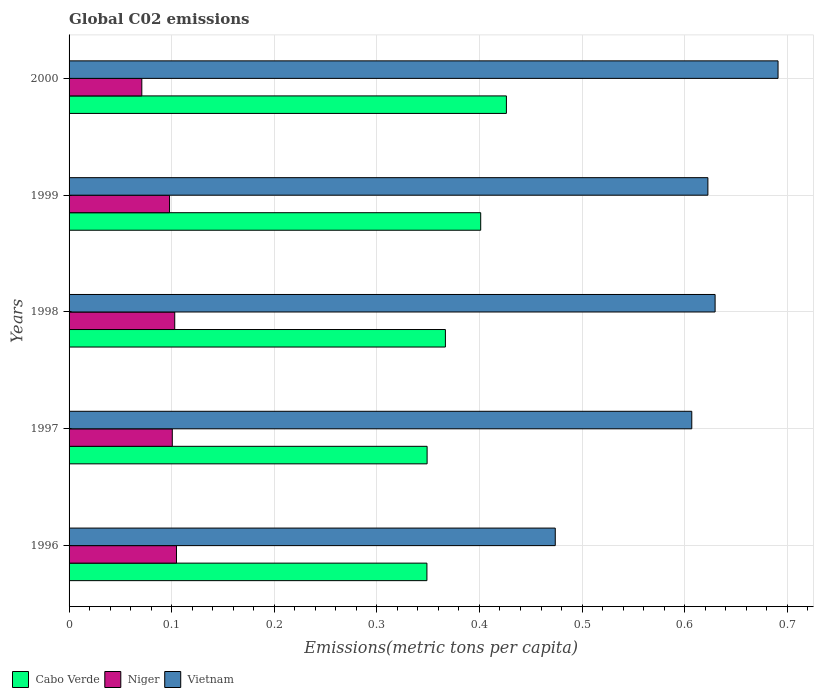Are the number of bars per tick equal to the number of legend labels?
Your answer should be compact. Yes. How many bars are there on the 2nd tick from the bottom?
Ensure brevity in your answer.  3. What is the label of the 3rd group of bars from the top?
Make the answer very short. 1998. What is the amount of CO2 emitted in in Vietnam in 1998?
Keep it short and to the point. 0.63. Across all years, what is the maximum amount of CO2 emitted in in Cabo Verde?
Your answer should be compact. 0.43. Across all years, what is the minimum amount of CO2 emitted in in Vietnam?
Your answer should be compact. 0.47. In which year was the amount of CO2 emitted in in Niger minimum?
Provide a succinct answer. 2000. What is the total amount of CO2 emitted in in Niger in the graph?
Your answer should be very brief. 0.48. What is the difference between the amount of CO2 emitted in in Niger in 1996 and that in 1997?
Your answer should be very brief. 0. What is the difference between the amount of CO2 emitted in in Vietnam in 1996 and the amount of CO2 emitted in in Niger in 2000?
Your answer should be very brief. 0.4. What is the average amount of CO2 emitted in in Niger per year?
Keep it short and to the point. 0.1. In the year 1998, what is the difference between the amount of CO2 emitted in in Cabo Verde and amount of CO2 emitted in in Vietnam?
Keep it short and to the point. -0.26. What is the ratio of the amount of CO2 emitted in in Cabo Verde in 1998 to that in 2000?
Give a very brief answer. 0.86. Is the amount of CO2 emitted in in Cabo Verde in 1999 less than that in 2000?
Your response must be concise. Yes. What is the difference between the highest and the second highest amount of CO2 emitted in in Cabo Verde?
Your answer should be very brief. 0.03. What is the difference between the highest and the lowest amount of CO2 emitted in in Vietnam?
Keep it short and to the point. 0.22. What does the 1st bar from the top in 2000 represents?
Ensure brevity in your answer.  Vietnam. What does the 1st bar from the bottom in 1999 represents?
Keep it short and to the point. Cabo Verde. Is it the case that in every year, the sum of the amount of CO2 emitted in in Niger and amount of CO2 emitted in in Cabo Verde is greater than the amount of CO2 emitted in in Vietnam?
Make the answer very short. No. How many bars are there?
Provide a short and direct response. 15. Are all the bars in the graph horizontal?
Give a very brief answer. Yes. What is the difference between two consecutive major ticks on the X-axis?
Your answer should be compact. 0.1. Are the values on the major ticks of X-axis written in scientific E-notation?
Keep it short and to the point. No. Does the graph contain any zero values?
Give a very brief answer. No. Where does the legend appear in the graph?
Ensure brevity in your answer.  Bottom left. How many legend labels are there?
Offer a terse response. 3. How are the legend labels stacked?
Make the answer very short. Horizontal. What is the title of the graph?
Your response must be concise. Global C02 emissions. What is the label or title of the X-axis?
Provide a short and direct response. Emissions(metric tons per capita). What is the Emissions(metric tons per capita) in Cabo Verde in 1996?
Offer a very short reply. 0.35. What is the Emissions(metric tons per capita) of Niger in 1996?
Your response must be concise. 0.1. What is the Emissions(metric tons per capita) of Vietnam in 1996?
Offer a very short reply. 0.47. What is the Emissions(metric tons per capita) in Cabo Verde in 1997?
Provide a succinct answer. 0.35. What is the Emissions(metric tons per capita) in Niger in 1997?
Offer a terse response. 0.1. What is the Emissions(metric tons per capita) in Vietnam in 1997?
Ensure brevity in your answer.  0.61. What is the Emissions(metric tons per capita) of Cabo Verde in 1998?
Give a very brief answer. 0.37. What is the Emissions(metric tons per capita) of Niger in 1998?
Ensure brevity in your answer.  0.1. What is the Emissions(metric tons per capita) of Vietnam in 1998?
Give a very brief answer. 0.63. What is the Emissions(metric tons per capita) in Cabo Verde in 1999?
Your answer should be compact. 0.4. What is the Emissions(metric tons per capita) of Niger in 1999?
Provide a succinct answer. 0.1. What is the Emissions(metric tons per capita) of Vietnam in 1999?
Offer a very short reply. 0.62. What is the Emissions(metric tons per capita) of Cabo Verde in 2000?
Ensure brevity in your answer.  0.43. What is the Emissions(metric tons per capita) in Niger in 2000?
Keep it short and to the point. 0.07. What is the Emissions(metric tons per capita) of Vietnam in 2000?
Your response must be concise. 0.69. Across all years, what is the maximum Emissions(metric tons per capita) in Cabo Verde?
Keep it short and to the point. 0.43. Across all years, what is the maximum Emissions(metric tons per capita) of Niger?
Provide a short and direct response. 0.1. Across all years, what is the maximum Emissions(metric tons per capita) in Vietnam?
Offer a terse response. 0.69. Across all years, what is the minimum Emissions(metric tons per capita) of Cabo Verde?
Provide a succinct answer. 0.35. Across all years, what is the minimum Emissions(metric tons per capita) in Niger?
Make the answer very short. 0.07. Across all years, what is the minimum Emissions(metric tons per capita) of Vietnam?
Make the answer very short. 0.47. What is the total Emissions(metric tons per capita) of Cabo Verde in the graph?
Provide a short and direct response. 1.89. What is the total Emissions(metric tons per capita) of Niger in the graph?
Give a very brief answer. 0.48. What is the total Emissions(metric tons per capita) of Vietnam in the graph?
Your answer should be very brief. 3.02. What is the difference between the Emissions(metric tons per capita) in Cabo Verde in 1996 and that in 1997?
Keep it short and to the point. -0. What is the difference between the Emissions(metric tons per capita) in Niger in 1996 and that in 1997?
Your answer should be compact. 0. What is the difference between the Emissions(metric tons per capita) in Vietnam in 1996 and that in 1997?
Provide a succinct answer. -0.13. What is the difference between the Emissions(metric tons per capita) of Cabo Verde in 1996 and that in 1998?
Your answer should be compact. -0.02. What is the difference between the Emissions(metric tons per capita) in Niger in 1996 and that in 1998?
Provide a short and direct response. 0. What is the difference between the Emissions(metric tons per capita) of Vietnam in 1996 and that in 1998?
Your answer should be very brief. -0.16. What is the difference between the Emissions(metric tons per capita) in Cabo Verde in 1996 and that in 1999?
Your response must be concise. -0.05. What is the difference between the Emissions(metric tons per capita) in Niger in 1996 and that in 1999?
Provide a succinct answer. 0.01. What is the difference between the Emissions(metric tons per capita) in Vietnam in 1996 and that in 1999?
Keep it short and to the point. -0.15. What is the difference between the Emissions(metric tons per capita) in Cabo Verde in 1996 and that in 2000?
Provide a short and direct response. -0.08. What is the difference between the Emissions(metric tons per capita) of Niger in 1996 and that in 2000?
Offer a very short reply. 0.03. What is the difference between the Emissions(metric tons per capita) of Vietnam in 1996 and that in 2000?
Your answer should be very brief. -0.22. What is the difference between the Emissions(metric tons per capita) in Cabo Verde in 1997 and that in 1998?
Provide a short and direct response. -0.02. What is the difference between the Emissions(metric tons per capita) in Niger in 1997 and that in 1998?
Offer a terse response. -0. What is the difference between the Emissions(metric tons per capita) of Vietnam in 1997 and that in 1998?
Ensure brevity in your answer.  -0.02. What is the difference between the Emissions(metric tons per capita) in Cabo Verde in 1997 and that in 1999?
Provide a short and direct response. -0.05. What is the difference between the Emissions(metric tons per capita) of Niger in 1997 and that in 1999?
Your response must be concise. 0. What is the difference between the Emissions(metric tons per capita) in Vietnam in 1997 and that in 1999?
Your answer should be compact. -0.02. What is the difference between the Emissions(metric tons per capita) of Cabo Verde in 1997 and that in 2000?
Your answer should be compact. -0.08. What is the difference between the Emissions(metric tons per capita) of Niger in 1997 and that in 2000?
Offer a very short reply. 0.03. What is the difference between the Emissions(metric tons per capita) of Vietnam in 1997 and that in 2000?
Give a very brief answer. -0.08. What is the difference between the Emissions(metric tons per capita) in Cabo Verde in 1998 and that in 1999?
Your answer should be very brief. -0.03. What is the difference between the Emissions(metric tons per capita) of Niger in 1998 and that in 1999?
Ensure brevity in your answer.  0.01. What is the difference between the Emissions(metric tons per capita) in Vietnam in 1998 and that in 1999?
Offer a terse response. 0.01. What is the difference between the Emissions(metric tons per capita) of Cabo Verde in 1998 and that in 2000?
Keep it short and to the point. -0.06. What is the difference between the Emissions(metric tons per capita) in Niger in 1998 and that in 2000?
Ensure brevity in your answer.  0.03. What is the difference between the Emissions(metric tons per capita) in Vietnam in 1998 and that in 2000?
Offer a very short reply. -0.06. What is the difference between the Emissions(metric tons per capita) of Cabo Verde in 1999 and that in 2000?
Make the answer very short. -0.03. What is the difference between the Emissions(metric tons per capita) of Niger in 1999 and that in 2000?
Your response must be concise. 0.03. What is the difference between the Emissions(metric tons per capita) in Vietnam in 1999 and that in 2000?
Offer a very short reply. -0.07. What is the difference between the Emissions(metric tons per capita) of Cabo Verde in 1996 and the Emissions(metric tons per capita) of Niger in 1997?
Give a very brief answer. 0.25. What is the difference between the Emissions(metric tons per capita) of Cabo Verde in 1996 and the Emissions(metric tons per capita) of Vietnam in 1997?
Ensure brevity in your answer.  -0.26. What is the difference between the Emissions(metric tons per capita) in Niger in 1996 and the Emissions(metric tons per capita) in Vietnam in 1997?
Your answer should be very brief. -0.5. What is the difference between the Emissions(metric tons per capita) in Cabo Verde in 1996 and the Emissions(metric tons per capita) in Niger in 1998?
Provide a succinct answer. 0.25. What is the difference between the Emissions(metric tons per capita) in Cabo Verde in 1996 and the Emissions(metric tons per capita) in Vietnam in 1998?
Give a very brief answer. -0.28. What is the difference between the Emissions(metric tons per capita) in Niger in 1996 and the Emissions(metric tons per capita) in Vietnam in 1998?
Keep it short and to the point. -0.53. What is the difference between the Emissions(metric tons per capita) of Cabo Verde in 1996 and the Emissions(metric tons per capita) of Niger in 1999?
Give a very brief answer. 0.25. What is the difference between the Emissions(metric tons per capita) in Cabo Verde in 1996 and the Emissions(metric tons per capita) in Vietnam in 1999?
Provide a short and direct response. -0.27. What is the difference between the Emissions(metric tons per capita) in Niger in 1996 and the Emissions(metric tons per capita) in Vietnam in 1999?
Make the answer very short. -0.52. What is the difference between the Emissions(metric tons per capita) of Cabo Verde in 1996 and the Emissions(metric tons per capita) of Niger in 2000?
Give a very brief answer. 0.28. What is the difference between the Emissions(metric tons per capita) of Cabo Verde in 1996 and the Emissions(metric tons per capita) of Vietnam in 2000?
Provide a short and direct response. -0.34. What is the difference between the Emissions(metric tons per capita) in Niger in 1996 and the Emissions(metric tons per capita) in Vietnam in 2000?
Offer a terse response. -0.59. What is the difference between the Emissions(metric tons per capita) in Cabo Verde in 1997 and the Emissions(metric tons per capita) in Niger in 1998?
Your response must be concise. 0.25. What is the difference between the Emissions(metric tons per capita) of Cabo Verde in 1997 and the Emissions(metric tons per capita) of Vietnam in 1998?
Give a very brief answer. -0.28. What is the difference between the Emissions(metric tons per capita) in Niger in 1997 and the Emissions(metric tons per capita) in Vietnam in 1998?
Offer a very short reply. -0.53. What is the difference between the Emissions(metric tons per capita) of Cabo Verde in 1997 and the Emissions(metric tons per capita) of Niger in 1999?
Make the answer very short. 0.25. What is the difference between the Emissions(metric tons per capita) of Cabo Verde in 1997 and the Emissions(metric tons per capita) of Vietnam in 1999?
Your response must be concise. -0.27. What is the difference between the Emissions(metric tons per capita) in Niger in 1997 and the Emissions(metric tons per capita) in Vietnam in 1999?
Offer a terse response. -0.52. What is the difference between the Emissions(metric tons per capita) of Cabo Verde in 1997 and the Emissions(metric tons per capita) of Niger in 2000?
Offer a very short reply. 0.28. What is the difference between the Emissions(metric tons per capita) of Cabo Verde in 1997 and the Emissions(metric tons per capita) of Vietnam in 2000?
Ensure brevity in your answer.  -0.34. What is the difference between the Emissions(metric tons per capita) of Niger in 1997 and the Emissions(metric tons per capita) of Vietnam in 2000?
Give a very brief answer. -0.59. What is the difference between the Emissions(metric tons per capita) of Cabo Verde in 1998 and the Emissions(metric tons per capita) of Niger in 1999?
Offer a very short reply. 0.27. What is the difference between the Emissions(metric tons per capita) of Cabo Verde in 1998 and the Emissions(metric tons per capita) of Vietnam in 1999?
Provide a succinct answer. -0.26. What is the difference between the Emissions(metric tons per capita) in Niger in 1998 and the Emissions(metric tons per capita) in Vietnam in 1999?
Your response must be concise. -0.52. What is the difference between the Emissions(metric tons per capita) of Cabo Verde in 1998 and the Emissions(metric tons per capita) of Niger in 2000?
Make the answer very short. 0.3. What is the difference between the Emissions(metric tons per capita) in Cabo Verde in 1998 and the Emissions(metric tons per capita) in Vietnam in 2000?
Provide a succinct answer. -0.32. What is the difference between the Emissions(metric tons per capita) in Niger in 1998 and the Emissions(metric tons per capita) in Vietnam in 2000?
Your response must be concise. -0.59. What is the difference between the Emissions(metric tons per capita) of Cabo Verde in 1999 and the Emissions(metric tons per capita) of Niger in 2000?
Offer a terse response. 0.33. What is the difference between the Emissions(metric tons per capita) in Cabo Verde in 1999 and the Emissions(metric tons per capita) in Vietnam in 2000?
Provide a short and direct response. -0.29. What is the difference between the Emissions(metric tons per capita) of Niger in 1999 and the Emissions(metric tons per capita) of Vietnam in 2000?
Offer a terse response. -0.59. What is the average Emissions(metric tons per capita) of Cabo Verde per year?
Ensure brevity in your answer.  0.38. What is the average Emissions(metric tons per capita) in Niger per year?
Your answer should be very brief. 0.1. What is the average Emissions(metric tons per capita) of Vietnam per year?
Give a very brief answer. 0.6. In the year 1996, what is the difference between the Emissions(metric tons per capita) in Cabo Verde and Emissions(metric tons per capita) in Niger?
Your response must be concise. 0.24. In the year 1996, what is the difference between the Emissions(metric tons per capita) of Cabo Verde and Emissions(metric tons per capita) of Vietnam?
Ensure brevity in your answer.  -0.13. In the year 1996, what is the difference between the Emissions(metric tons per capita) of Niger and Emissions(metric tons per capita) of Vietnam?
Your answer should be very brief. -0.37. In the year 1997, what is the difference between the Emissions(metric tons per capita) in Cabo Verde and Emissions(metric tons per capita) in Niger?
Your answer should be very brief. 0.25. In the year 1997, what is the difference between the Emissions(metric tons per capita) of Cabo Verde and Emissions(metric tons per capita) of Vietnam?
Your response must be concise. -0.26. In the year 1997, what is the difference between the Emissions(metric tons per capita) in Niger and Emissions(metric tons per capita) in Vietnam?
Offer a very short reply. -0.51. In the year 1998, what is the difference between the Emissions(metric tons per capita) in Cabo Verde and Emissions(metric tons per capita) in Niger?
Keep it short and to the point. 0.26. In the year 1998, what is the difference between the Emissions(metric tons per capita) of Cabo Verde and Emissions(metric tons per capita) of Vietnam?
Offer a terse response. -0.26. In the year 1998, what is the difference between the Emissions(metric tons per capita) of Niger and Emissions(metric tons per capita) of Vietnam?
Make the answer very short. -0.53. In the year 1999, what is the difference between the Emissions(metric tons per capita) in Cabo Verde and Emissions(metric tons per capita) in Niger?
Provide a succinct answer. 0.3. In the year 1999, what is the difference between the Emissions(metric tons per capita) of Cabo Verde and Emissions(metric tons per capita) of Vietnam?
Offer a terse response. -0.22. In the year 1999, what is the difference between the Emissions(metric tons per capita) in Niger and Emissions(metric tons per capita) in Vietnam?
Offer a very short reply. -0.52. In the year 2000, what is the difference between the Emissions(metric tons per capita) of Cabo Verde and Emissions(metric tons per capita) of Niger?
Offer a terse response. 0.36. In the year 2000, what is the difference between the Emissions(metric tons per capita) in Cabo Verde and Emissions(metric tons per capita) in Vietnam?
Ensure brevity in your answer.  -0.26. In the year 2000, what is the difference between the Emissions(metric tons per capita) in Niger and Emissions(metric tons per capita) in Vietnam?
Make the answer very short. -0.62. What is the ratio of the Emissions(metric tons per capita) of Niger in 1996 to that in 1997?
Keep it short and to the point. 1.04. What is the ratio of the Emissions(metric tons per capita) in Vietnam in 1996 to that in 1997?
Keep it short and to the point. 0.78. What is the ratio of the Emissions(metric tons per capita) in Cabo Verde in 1996 to that in 1998?
Provide a succinct answer. 0.95. What is the ratio of the Emissions(metric tons per capita) of Niger in 1996 to that in 1998?
Your answer should be very brief. 1.02. What is the ratio of the Emissions(metric tons per capita) of Vietnam in 1996 to that in 1998?
Your response must be concise. 0.75. What is the ratio of the Emissions(metric tons per capita) in Cabo Verde in 1996 to that in 1999?
Provide a short and direct response. 0.87. What is the ratio of the Emissions(metric tons per capita) of Niger in 1996 to that in 1999?
Your response must be concise. 1.07. What is the ratio of the Emissions(metric tons per capita) in Vietnam in 1996 to that in 1999?
Keep it short and to the point. 0.76. What is the ratio of the Emissions(metric tons per capita) of Cabo Verde in 1996 to that in 2000?
Provide a short and direct response. 0.82. What is the ratio of the Emissions(metric tons per capita) in Niger in 1996 to that in 2000?
Make the answer very short. 1.48. What is the ratio of the Emissions(metric tons per capita) in Vietnam in 1996 to that in 2000?
Your answer should be very brief. 0.69. What is the ratio of the Emissions(metric tons per capita) in Cabo Verde in 1997 to that in 1998?
Offer a very short reply. 0.95. What is the ratio of the Emissions(metric tons per capita) in Niger in 1997 to that in 1998?
Offer a very short reply. 0.98. What is the ratio of the Emissions(metric tons per capita) in Vietnam in 1997 to that in 1998?
Ensure brevity in your answer.  0.96. What is the ratio of the Emissions(metric tons per capita) in Cabo Verde in 1997 to that in 1999?
Your response must be concise. 0.87. What is the ratio of the Emissions(metric tons per capita) of Niger in 1997 to that in 1999?
Ensure brevity in your answer.  1.03. What is the ratio of the Emissions(metric tons per capita) of Vietnam in 1997 to that in 1999?
Ensure brevity in your answer.  0.97. What is the ratio of the Emissions(metric tons per capita) of Cabo Verde in 1997 to that in 2000?
Ensure brevity in your answer.  0.82. What is the ratio of the Emissions(metric tons per capita) of Niger in 1997 to that in 2000?
Offer a very short reply. 1.42. What is the ratio of the Emissions(metric tons per capita) of Vietnam in 1997 to that in 2000?
Offer a terse response. 0.88. What is the ratio of the Emissions(metric tons per capita) in Cabo Verde in 1998 to that in 1999?
Make the answer very short. 0.91. What is the ratio of the Emissions(metric tons per capita) in Niger in 1998 to that in 1999?
Ensure brevity in your answer.  1.05. What is the ratio of the Emissions(metric tons per capita) of Vietnam in 1998 to that in 1999?
Your answer should be compact. 1.01. What is the ratio of the Emissions(metric tons per capita) in Cabo Verde in 1998 to that in 2000?
Your answer should be compact. 0.86. What is the ratio of the Emissions(metric tons per capita) of Niger in 1998 to that in 2000?
Offer a terse response. 1.45. What is the ratio of the Emissions(metric tons per capita) in Vietnam in 1998 to that in 2000?
Your answer should be very brief. 0.91. What is the ratio of the Emissions(metric tons per capita) in Cabo Verde in 1999 to that in 2000?
Your answer should be compact. 0.94. What is the ratio of the Emissions(metric tons per capita) in Niger in 1999 to that in 2000?
Provide a succinct answer. 1.38. What is the ratio of the Emissions(metric tons per capita) in Vietnam in 1999 to that in 2000?
Provide a short and direct response. 0.9. What is the difference between the highest and the second highest Emissions(metric tons per capita) in Cabo Verde?
Ensure brevity in your answer.  0.03. What is the difference between the highest and the second highest Emissions(metric tons per capita) of Niger?
Provide a short and direct response. 0. What is the difference between the highest and the second highest Emissions(metric tons per capita) of Vietnam?
Make the answer very short. 0.06. What is the difference between the highest and the lowest Emissions(metric tons per capita) of Cabo Verde?
Ensure brevity in your answer.  0.08. What is the difference between the highest and the lowest Emissions(metric tons per capita) in Niger?
Offer a very short reply. 0.03. What is the difference between the highest and the lowest Emissions(metric tons per capita) in Vietnam?
Ensure brevity in your answer.  0.22. 